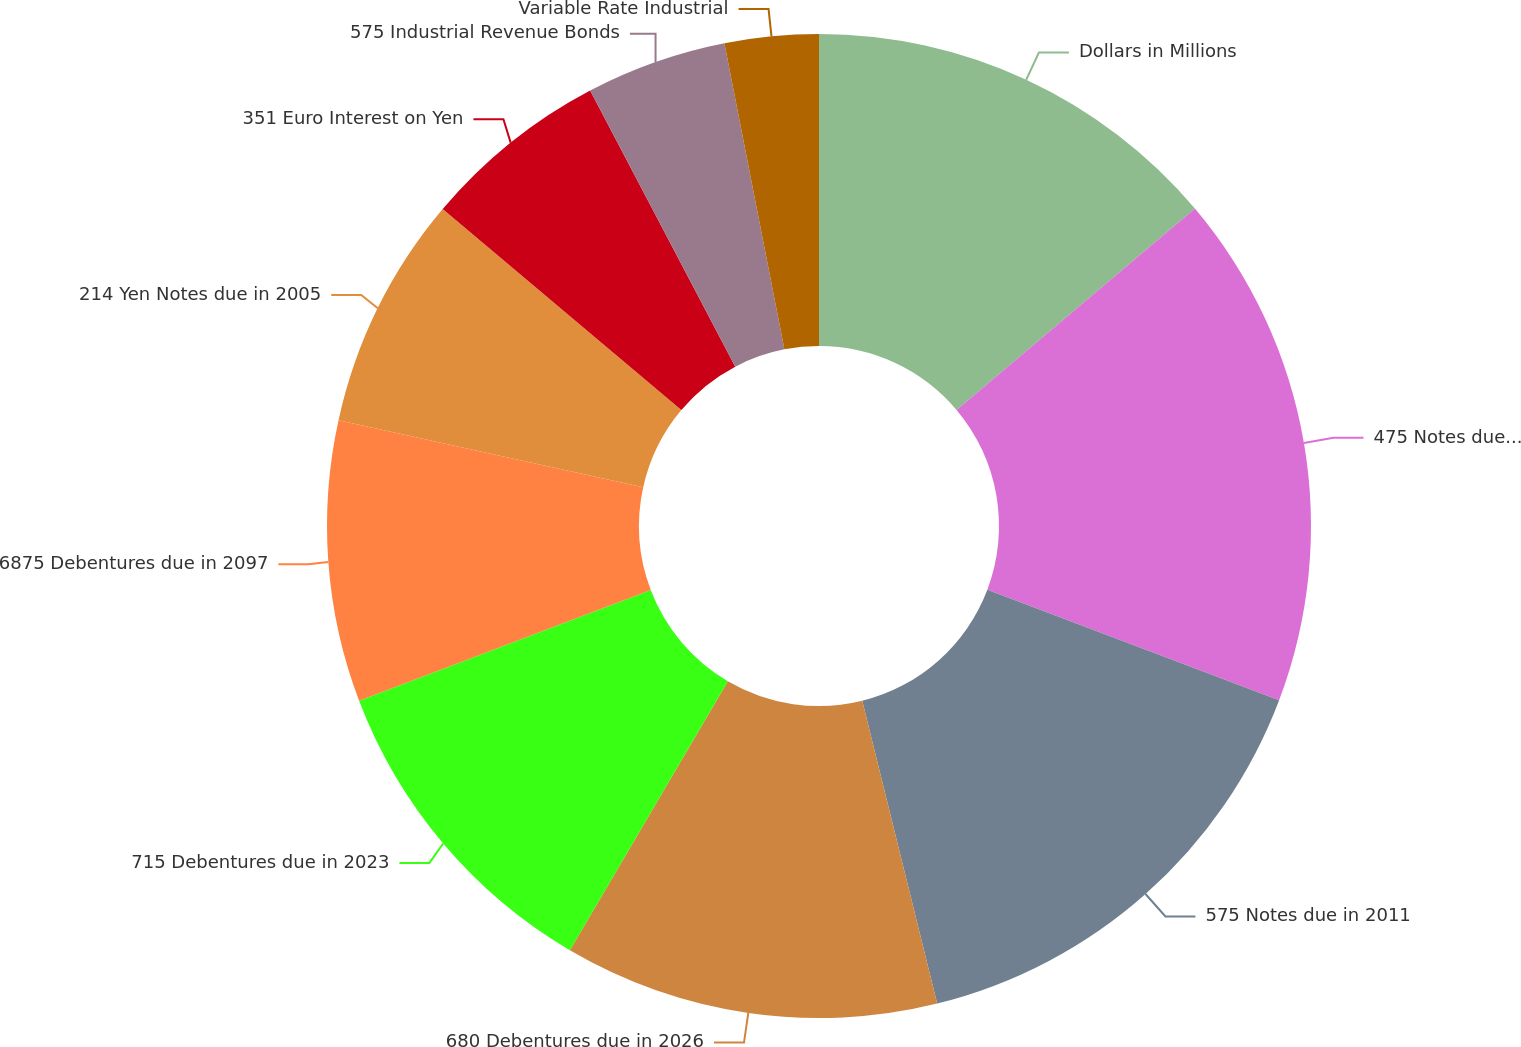<chart> <loc_0><loc_0><loc_500><loc_500><pie_chart><fcel>Dollars in Millions<fcel>475 Notes due in 2006<fcel>575 Notes due in 2011<fcel>680 Debentures due in 2026<fcel>715 Debentures due in 2023<fcel>6875 Debentures due in 2097<fcel>214 Yen Notes due in 2005<fcel>351 Euro Interest on Yen<fcel>575 Industrial Revenue Bonds<fcel>Variable Rate Industrial<nl><fcel>13.84%<fcel>16.92%<fcel>15.38%<fcel>12.31%<fcel>10.77%<fcel>9.23%<fcel>7.69%<fcel>6.16%<fcel>4.62%<fcel>3.08%<nl></chart> 